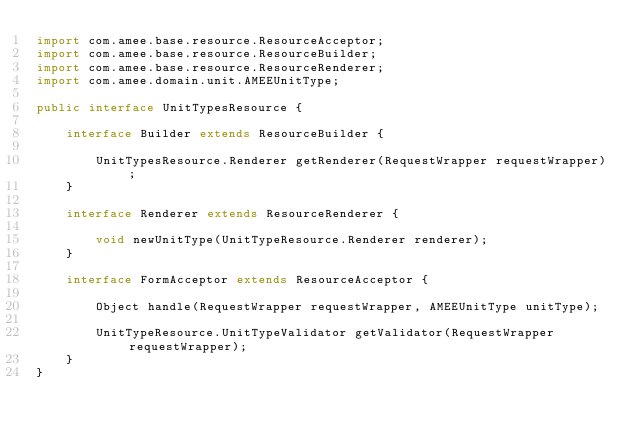<code> <loc_0><loc_0><loc_500><loc_500><_Java_>import com.amee.base.resource.ResourceAcceptor;
import com.amee.base.resource.ResourceBuilder;
import com.amee.base.resource.ResourceRenderer;
import com.amee.domain.unit.AMEEUnitType;

public interface UnitTypesResource {

    interface Builder extends ResourceBuilder {

        UnitTypesResource.Renderer getRenderer(RequestWrapper requestWrapper);
    }

    interface Renderer extends ResourceRenderer {

        void newUnitType(UnitTypeResource.Renderer renderer);
    }

    interface FormAcceptor extends ResourceAcceptor {

        Object handle(RequestWrapper requestWrapper, AMEEUnitType unitType);

        UnitTypeResource.UnitTypeValidator getValidator(RequestWrapper requestWrapper);
    }
}</code> 